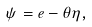<formula> <loc_0><loc_0><loc_500><loc_500>\psi = e - \theta \eta ,</formula> 